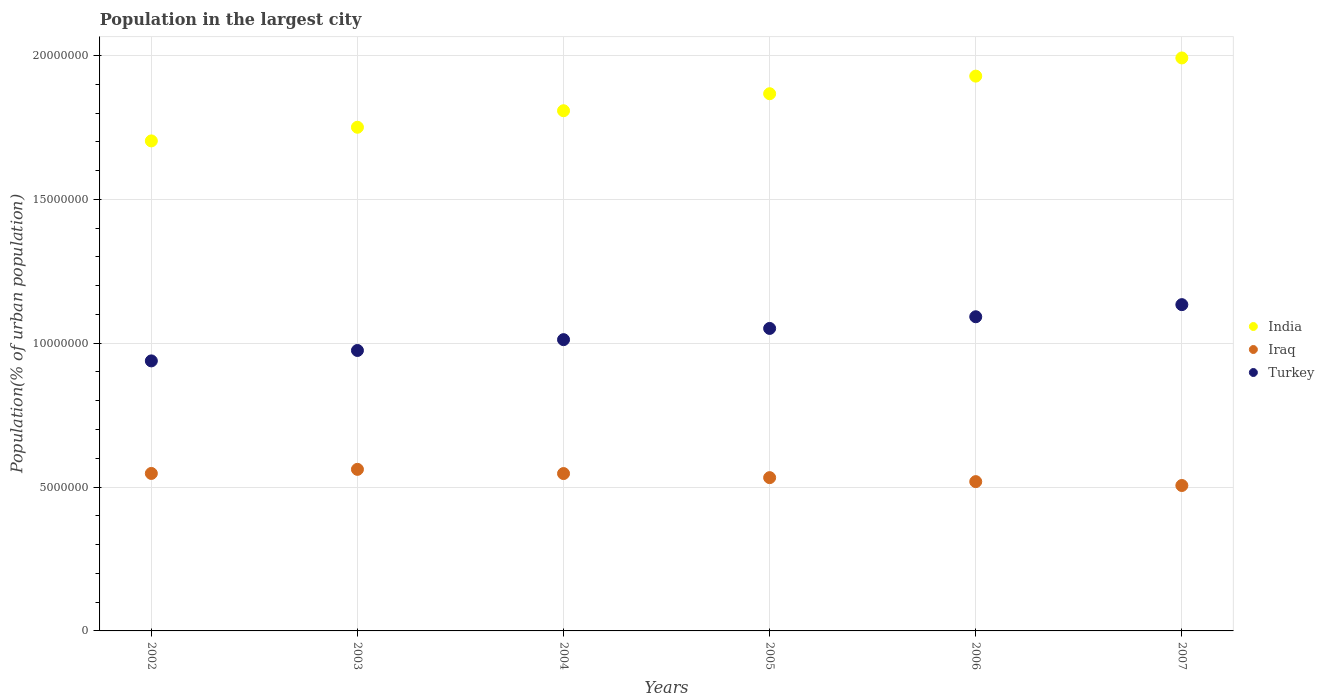Is the number of dotlines equal to the number of legend labels?
Make the answer very short. Yes. What is the population in the largest city in Turkey in 2006?
Make the answer very short. 1.09e+07. Across all years, what is the maximum population in the largest city in Turkey?
Ensure brevity in your answer.  1.13e+07. Across all years, what is the minimum population in the largest city in Turkey?
Give a very brief answer. 9.38e+06. In which year was the population in the largest city in Iraq maximum?
Offer a very short reply. 2003. In which year was the population in the largest city in Iraq minimum?
Give a very brief answer. 2007. What is the total population in the largest city in India in the graph?
Your answer should be very brief. 1.10e+08. What is the difference between the population in the largest city in Turkey in 2004 and that in 2006?
Make the answer very short. -7.95e+05. What is the difference between the population in the largest city in Iraq in 2005 and the population in the largest city in India in 2007?
Provide a succinct answer. -1.46e+07. What is the average population in the largest city in Turkey per year?
Provide a short and direct response. 1.03e+07. In the year 2002, what is the difference between the population in the largest city in Iraq and population in the largest city in Turkey?
Provide a short and direct response. -3.91e+06. In how many years, is the population in the largest city in Iraq greater than 11000000 %?
Your answer should be very brief. 0. What is the ratio of the population in the largest city in Iraq in 2003 to that in 2005?
Your response must be concise. 1.05. What is the difference between the highest and the second highest population in the largest city in Iraq?
Your answer should be compact. 1.42e+05. What is the difference between the highest and the lowest population in the largest city in India?
Keep it short and to the point. 2.88e+06. In how many years, is the population in the largest city in Iraq greater than the average population in the largest city in Iraq taken over all years?
Offer a very short reply. 3. Is the population in the largest city in Turkey strictly greater than the population in the largest city in India over the years?
Provide a short and direct response. No. How many dotlines are there?
Make the answer very short. 3. How many years are there in the graph?
Ensure brevity in your answer.  6. What is the difference between two consecutive major ticks on the Y-axis?
Ensure brevity in your answer.  5.00e+06. Are the values on the major ticks of Y-axis written in scientific E-notation?
Your response must be concise. No. Where does the legend appear in the graph?
Ensure brevity in your answer.  Center right. How are the legend labels stacked?
Provide a short and direct response. Vertical. What is the title of the graph?
Ensure brevity in your answer.  Population in the largest city. Does "Guatemala" appear as one of the legend labels in the graph?
Make the answer very short. No. What is the label or title of the Y-axis?
Your answer should be very brief. Population(% of urban population). What is the Population(% of urban population) of India in 2002?
Offer a terse response. 1.70e+07. What is the Population(% of urban population) of Iraq in 2002?
Provide a short and direct response. 5.47e+06. What is the Population(% of urban population) in Turkey in 2002?
Your answer should be very brief. 9.38e+06. What is the Population(% of urban population) of India in 2003?
Provide a succinct answer. 1.75e+07. What is the Population(% of urban population) in Iraq in 2003?
Keep it short and to the point. 5.62e+06. What is the Population(% of urban population) of Turkey in 2003?
Provide a succinct answer. 9.75e+06. What is the Population(% of urban population) of India in 2004?
Your answer should be very brief. 1.81e+07. What is the Population(% of urban population) of Iraq in 2004?
Offer a very short reply. 5.47e+06. What is the Population(% of urban population) in Turkey in 2004?
Keep it short and to the point. 1.01e+07. What is the Population(% of urban population) in India in 2005?
Keep it short and to the point. 1.87e+07. What is the Population(% of urban population) in Iraq in 2005?
Your answer should be very brief. 5.33e+06. What is the Population(% of urban population) in Turkey in 2005?
Keep it short and to the point. 1.05e+07. What is the Population(% of urban population) of India in 2006?
Your answer should be very brief. 1.93e+07. What is the Population(% of urban population) in Iraq in 2006?
Ensure brevity in your answer.  5.19e+06. What is the Population(% of urban population) of Turkey in 2006?
Make the answer very short. 1.09e+07. What is the Population(% of urban population) in India in 2007?
Your response must be concise. 1.99e+07. What is the Population(% of urban population) of Iraq in 2007?
Provide a short and direct response. 5.05e+06. What is the Population(% of urban population) of Turkey in 2007?
Offer a very short reply. 1.13e+07. Across all years, what is the maximum Population(% of urban population) in India?
Your answer should be very brief. 1.99e+07. Across all years, what is the maximum Population(% of urban population) of Iraq?
Your response must be concise. 5.62e+06. Across all years, what is the maximum Population(% of urban population) of Turkey?
Give a very brief answer. 1.13e+07. Across all years, what is the minimum Population(% of urban population) in India?
Make the answer very short. 1.70e+07. Across all years, what is the minimum Population(% of urban population) in Iraq?
Give a very brief answer. 5.05e+06. Across all years, what is the minimum Population(% of urban population) of Turkey?
Offer a terse response. 9.38e+06. What is the total Population(% of urban population) of India in the graph?
Provide a short and direct response. 1.10e+08. What is the total Population(% of urban population) in Iraq in the graph?
Make the answer very short. 3.21e+07. What is the total Population(% of urban population) of Turkey in the graph?
Ensure brevity in your answer.  6.20e+07. What is the difference between the Population(% of urban population) in India in 2002 and that in 2003?
Your answer should be very brief. -4.74e+05. What is the difference between the Population(% of urban population) of Iraq in 2002 and that in 2003?
Offer a terse response. -1.42e+05. What is the difference between the Population(% of urban population) in Turkey in 2002 and that in 2003?
Your response must be concise. -3.62e+05. What is the difference between the Population(% of urban population) in India in 2002 and that in 2004?
Your answer should be very brief. -1.05e+06. What is the difference between the Population(% of urban population) in Iraq in 2002 and that in 2004?
Keep it short and to the point. 4024. What is the difference between the Population(% of urban population) in Turkey in 2002 and that in 2004?
Ensure brevity in your answer.  -7.38e+05. What is the difference between the Population(% of urban population) in India in 2002 and that in 2005?
Make the answer very short. -1.64e+06. What is the difference between the Population(% of urban population) of Iraq in 2002 and that in 2005?
Your response must be concise. 1.46e+05. What is the difference between the Population(% of urban population) of Turkey in 2002 and that in 2005?
Give a very brief answer. -1.13e+06. What is the difference between the Population(% of urban population) of India in 2002 and that in 2006?
Offer a very short reply. -2.25e+06. What is the difference between the Population(% of urban population) of Iraq in 2002 and that in 2006?
Keep it short and to the point. 2.84e+05. What is the difference between the Population(% of urban population) in Turkey in 2002 and that in 2006?
Offer a terse response. -1.53e+06. What is the difference between the Population(% of urban population) in India in 2002 and that in 2007?
Make the answer very short. -2.88e+06. What is the difference between the Population(% of urban population) in Iraq in 2002 and that in 2007?
Keep it short and to the point. 4.19e+05. What is the difference between the Population(% of urban population) of Turkey in 2002 and that in 2007?
Make the answer very short. -1.96e+06. What is the difference between the Population(% of urban population) in India in 2003 and that in 2004?
Make the answer very short. -5.74e+05. What is the difference between the Population(% of urban population) of Iraq in 2003 and that in 2004?
Give a very brief answer. 1.46e+05. What is the difference between the Population(% of urban population) in Turkey in 2003 and that in 2004?
Ensure brevity in your answer.  -3.76e+05. What is the difference between the Population(% of urban population) in India in 2003 and that in 2005?
Give a very brief answer. -1.17e+06. What is the difference between the Population(% of urban population) of Iraq in 2003 and that in 2005?
Offer a terse response. 2.88e+05. What is the difference between the Population(% of urban population) of Turkey in 2003 and that in 2005?
Your response must be concise. -7.66e+05. What is the difference between the Population(% of urban population) of India in 2003 and that in 2006?
Your answer should be very brief. -1.78e+06. What is the difference between the Population(% of urban population) of Iraq in 2003 and that in 2006?
Give a very brief answer. 4.26e+05. What is the difference between the Population(% of urban population) of Turkey in 2003 and that in 2006?
Offer a very short reply. -1.17e+06. What is the difference between the Population(% of urban population) of India in 2003 and that in 2007?
Offer a very short reply. -2.41e+06. What is the difference between the Population(% of urban population) of Iraq in 2003 and that in 2007?
Ensure brevity in your answer.  5.61e+05. What is the difference between the Population(% of urban population) in Turkey in 2003 and that in 2007?
Offer a terse response. -1.59e+06. What is the difference between the Population(% of urban population) in India in 2004 and that in 2005?
Your answer should be very brief. -5.91e+05. What is the difference between the Population(% of urban population) of Iraq in 2004 and that in 2005?
Provide a short and direct response. 1.42e+05. What is the difference between the Population(% of urban population) in Turkey in 2004 and that in 2005?
Offer a terse response. -3.90e+05. What is the difference between the Population(% of urban population) in India in 2004 and that in 2006?
Make the answer very short. -1.20e+06. What is the difference between the Population(% of urban population) of Iraq in 2004 and that in 2006?
Your response must be concise. 2.80e+05. What is the difference between the Population(% of urban population) in Turkey in 2004 and that in 2006?
Your answer should be very brief. -7.95e+05. What is the difference between the Population(% of urban population) of India in 2004 and that in 2007?
Offer a terse response. -1.83e+06. What is the difference between the Population(% of urban population) in Iraq in 2004 and that in 2007?
Make the answer very short. 4.15e+05. What is the difference between the Population(% of urban population) of Turkey in 2004 and that in 2007?
Make the answer very short. -1.22e+06. What is the difference between the Population(% of urban population) of India in 2005 and that in 2006?
Your response must be concise. -6.12e+05. What is the difference between the Population(% of urban population) of Iraq in 2005 and that in 2006?
Provide a succinct answer. 1.38e+05. What is the difference between the Population(% of urban population) of Turkey in 2005 and that in 2006?
Your answer should be compact. -4.06e+05. What is the difference between the Population(% of urban population) in India in 2005 and that in 2007?
Offer a terse response. -1.24e+06. What is the difference between the Population(% of urban population) in Iraq in 2005 and that in 2007?
Give a very brief answer. 2.73e+05. What is the difference between the Population(% of urban population) of Turkey in 2005 and that in 2007?
Your answer should be very brief. -8.27e+05. What is the difference between the Population(% of urban population) of India in 2006 and that in 2007?
Offer a very short reply. -6.32e+05. What is the difference between the Population(% of urban population) of Iraq in 2006 and that in 2007?
Make the answer very short. 1.35e+05. What is the difference between the Population(% of urban population) in Turkey in 2006 and that in 2007?
Offer a terse response. -4.21e+05. What is the difference between the Population(% of urban population) of India in 2002 and the Population(% of urban population) of Iraq in 2003?
Your answer should be compact. 1.14e+07. What is the difference between the Population(% of urban population) of India in 2002 and the Population(% of urban population) of Turkey in 2003?
Make the answer very short. 7.28e+06. What is the difference between the Population(% of urban population) in Iraq in 2002 and the Population(% of urban population) in Turkey in 2003?
Provide a short and direct response. -4.27e+06. What is the difference between the Population(% of urban population) in India in 2002 and the Population(% of urban population) in Iraq in 2004?
Offer a terse response. 1.16e+07. What is the difference between the Population(% of urban population) in India in 2002 and the Population(% of urban population) in Turkey in 2004?
Your response must be concise. 6.91e+06. What is the difference between the Population(% of urban population) in Iraq in 2002 and the Population(% of urban population) in Turkey in 2004?
Provide a short and direct response. -4.65e+06. What is the difference between the Population(% of urban population) in India in 2002 and the Population(% of urban population) in Iraq in 2005?
Provide a succinct answer. 1.17e+07. What is the difference between the Population(% of urban population) in India in 2002 and the Population(% of urban population) in Turkey in 2005?
Your answer should be very brief. 6.52e+06. What is the difference between the Population(% of urban population) of Iraq in 2002 and the Population(% of urban population) of Turkey in 2005?
Give a very brief answer. -5.04e+06. What is the difference between the Population(% of urban population) in India in 2002 and the Population(% of urban population) in Iraq in 2006?
Make the answer very short. 1.18e+07. What is the difference between the Population(% of urban population) in India in 2002 and the Population(% of urban population) in Turkey in 2006?
Offer a very short reply. 6.11e+06. What is the difference between the Population(% of urban population) of Iraq in 2002 and the Population(% of urban population) of Turkey in 2006?
Offer a terse response. -5.45e+06. What is the difference between the Population(% of urban population) of India in 2002 and the Population(% of urban population) of Iraq in 2007?
Provide a succinct answer. 1.20e+07. What is the difference between the Population(% of urban population) in India in 2002 and the Population(% of urban population) in Turkey in 2007?
Give a very brief answer. 5.69e+06. What is the difference between the Population(% of urban population) in Iraq in 2002 and the Population(% of urban population) in Turkey in 2007?
Offer a terse response. -5.87e+06. What is the difference between the Population(% of urban population) in India in 2003 and the Population(% of urban population) in Iraq in 2004?
Your answer should be very brief. 1.20e+07. What is the difference between the Population(% of urban population) of India in 2003 and the Population(% of urban population) of Turkey in 2004?
Make the answer very short. 7.38e+06. What is the difference between the Population(% of urban population) in Iraq in 2003 and the Population(% of urban population) in Turkey in 2004?
Offer a terse response. -4.51e+06. What is the difference between the Population(% of urban population) in India in 2003 and the Population(% of urban population) in Iraq in 2005?
Provide a succinct answer. 1.22e+07. What is the difference between the Population(% of urban population) of India in 2003 and the Population(% of urban population) of Turkey in 2005?
Your answer should be compact. 6.99e+06. What is the difference between the Population(% of urban population) in Iraq in 2003 and the Population(% of urban population) in Turkey in 2005?
Offer a terse response. -4.90e+06. What is the difference between the Population(% of urban population) of India in 2003 and the Population(% of urban population) of Iraq in 2006?
Your answer should be compact. 1.23e+07. What is the difference between the Population(% of urban population) of India in 2003 and the Population(% of urban population) of Turkey in 2006?
Your answer should be compact. 6.59e+06. What is the difference between the Population(% of urban population) of Iraq in 2003 and the Population(% of urban population) of Turkey in 2006?
Your response must be concise. -5.30e+06. What is the difference between the Population(% of urban population) of India in 2003 and the Population(% of urban population) of Iraq in 2007?
Your response must be concise. 1.25e+07. What is the difference between the Population(% of urban population) in India in 2003 and the Population(% of urban population) in Turkey in 2007?
Keep it short and to the point. 6.17e+06. What is the difference between the Population(% of urban population) of Iraq in 2003 and the Population(% of urban population) of Turkey in 2007?
Your answer should be compact. -5.72e+06. What is the difference between the Population(% of urban population) in India in 2004 and the Population(% of urban population) in Iraq in 2005?
Your response must be concise. 1.28e+07. What is the difference between the Population(% of urban population) of India in 2004 and the Population(% of urban population) of Turkey in 2005?
Your answer should be compact. 7.57e+06. What is the difference between the Population(% of urban population) of Iraq in 2004 and the Population(% of urban population) of Turkey in 2005?
Offer a terse response. -5.04e+06. What is the difference between the Population(% of urban population) in India in 2004 and the Population(% of urban population) in Iraq in 2006?
Offer a very short reply. 1.29e+07. What is the difference between the Population(% of urban population) of India in 2004 and the Population(% of urban population) of Turkey in 2006?
Make the answer very short. 7.16e+06. What is the difference between the Population(% of urban population) of Iraq in 2004 and the Population(% of urban population) of Turkey in 2006?
Ensure brevity in your answer.  -5.45e+06. What is the difference between the Population(% of urban population) of India in 2004 and the Population(% of urban population) of Iraq in 2007?
Your answer should be compact. 1.30e+07. What is the difference between the Population(% of urban population) of India in 2004 and the Population(% of urban population) of Turkey in 2007?
Your answer should be compact. 6.74e+06. What is the difference between the Population(% of urban population) in Iraq in 2004 and the Population(% of urban population) in Turkey in 2007?
Your answer should be very brief. -5.87e+06. What is the difference between the Population(% of urban population) of India in 2005 and the Population(% of urban population) of Iraq in 2006?
Your response must be concise. 1.35e+07. What is the difference between the Population(% of urban population) of India in 2005 and the Population(% of urban population) of Turkey in 2006?
Your answer should be compact. 7.75e+06. What is the difference between the Population(% of urban population) in Iraq in 2005 and the Population(% of urban population) in Turkey in 2006?
Give a very brief answer. -5.59e+06. What is the difference between the Population(% of urban population) of India in 2005 and the Population(% of urban population) of Iraq in 2007?
Your answer should be very brief. 1.36e+07. What is the difference between the Population(% of urban population) in India in 2005 and the Population(% of urban population) in Turkey in 2007?
Your answer should be very brief. 7.33e+06. What is the difference between the Population(% of urban population) in Iraq in 2005 and the Population(% of urban population) in Turkey in 2007?
Provide a short and direct response. -6.01e+06. What is the difference between the Population(% of urban population) in India in 2006 and the Population(% of urban population) in Iraq in 2007?
Make the answer very short. 1.42e+07. What is the difference between the Population(% of urban population) in India in 2006 and the Population(% of urban population) in Turkey in 2007?
Make the answer very short. 7.94e+06. What is the difference between the Population(% of urban population) of Iraq in 2006 and the Population(% of urban population) of Turkey in 2007?
Your answer should be very brief. -6.15e+06. What is the average Population(% of urban population) of India per year?
Offer a very short reply. 1.84e+07. What is the average Population(% of urban population) of Iraq per year?
Give a very brief answer. 5.35e+06. What is the average Population(% of urban population) of Turkey per year?
Give a very brief answer. 1.03e+07. In the year 2002, what is the difference between the Population(% of urban population) of India and Population(% of urban population) of Iraq?
Your answer should be compact. 1.16e+07. In the year 2002, what is the difference between the Population(% of urban population) in India and Population(% of urban population) in Turkey?
Your answer should be compact. 7.65e+06. In the year 2002, what is the difference between the Population(% of urban population) of Iraq and Population(% of urban population) of Turkey?
Ensure brevity in your answer.  -3.91e+06. In the year 2003, what is the difference between the Population(% of urban population) of India and Population(% of urban population) of Iraq?
Ensure brevity in your answer.  1.19e+07. In the year 2003, what is the difference between the Population(% of urban population) in India and Population(% of urban population) in Turkey?
Offer a very short reply. 7.76e+06. In the year 2003, what is the difference between the Population(% of urban population) of Iraq and Population(% of urban population) of Turkey?
Keep it short and to the point. -4.13e+06. In the year 2004, what is the difference between the Population(% of urban population) in India and Population(% of urban population) in Iraq?
Your answer should be compact. 1.26e+07. In the year 2004, what is the difference between the Population(% of urban population) in India and Population(% of urban population) in Turkey?
Offer a very short reply. 7.96e+06. In the year 2004, what is the difference between the Population(% of urban population) in Iraq and Population(% of urban population) in Turkey?
Your answer should be very brief. -4.65e+06. In the year 2005, what is the difference between the Population(% of urban population) in India and Population(% of urban population) in Iraq?
Keep it short and to the point. 1.33e+07. In the year 2005, what is the difference between the Population(% of urban population) of India and Population(% of urban population) of Turkey?
Make the answer very short. 8.16e+06. In the year 2005, what is the difference between the Population(% of urban population) in Iraq and Population(% of urban population) in Turkey?
Ensure brevity in your answer.  -5.19e+06. In the year 2006, what is the difference between the Population(% of urban population) of India and Population(% of urban population) of Iraq?
Make the answer very short. 1.41e+07. In the year 2006, what is the difference between the Population(% of urban population) in India and Population(% of urban population) in Turkey?
Your answer should be compact. 8.36e+06. In the year 2006, what is the difference between the Population(% of urban population) of Iraq and Population(% of urban population) of Turkey?
Your answer should be compact. -5.73e+06. In the year 2007, what is the difference between the Population(% of urban population) of India and Population(% of urban population) of Iraq?
Make the answer very short. 1.49e+07. In the year 2007, what is the difference between the Population(% of urban population) of India and Population(% of urban population) of Turkey?
Offer a very short reply. 8.57e+06. In the year 2007, what is the difference between the Population(% of urban population) in Iraq and Population(% of urban population) in Turkey?
Ensure brevity in your answer.  -6.29e+06. What is the ratio of the Population(% of urban population) in India in 2002 to that in 2003?
Offer a very short reply. 0.97. What is the ratio of the Population(% of urban population) of Iraq in 2002 to that in 2003?
Provide a short and direct response. 0.97. What is the ratio of the Population(% of urban population) in Turkey in 2002 to that in 2003?
Give a very brief answer. 0.96. What is the ratio of the Population(% of urban population) in India in 2002 to that in 2004?
Keep it short and to the point. 0.94. What is the ratio of the Population(% of urban population) in Iraq in 2002 to that in 2004?
Your answer should be very brief. 1. What is the ratio of the Population(% of urban population) of Turkey in 2002 to that in 2004?
Give a very brief answer. 0.93. What is the ratio of the Population(% of urban population) of India in 2002 to that in 2005?
Provide a short and direct response. 0.91. What is the ratio of the Population(% of urban population) of Iraq in 2002 to that in 2005?
Offer a terse response. 1.03. What is the ratio of the Population(% of urban population) of Turkey in 2002 to that in 2005?
Give a very brief answer. 0.89. What is the ratio of the Population(% of urban population) of India in 2002 to that in 2006?
Ensure brevity in your answer.  0.88. What is the ratio of the Population(% of urban population) in Iraq in 2002 to that in 2006?
Make the answer very short. 1.05. What is the ratio of the Population(% of urban population) in Turkey in 2002 to that in 2006?
Provide a short and direct response. 0.86. What is the ratio of the Population(% of urban population) in India in 2002 to that in 2007?
Ensure brevity in your answer.  0.86. What is the ratio of the Population(% of urban population) in Iraq in 2002 to that in 2007?
Offer a very short reply. 1.08. What is the ratio of the Population(% of urban population) in Turkey in 2002 to that in 2007?
Your answer should be very brief. 0.83. What is the ratio of the Population(% of urban population) in India in 2003 to that in 2004?
Provide a succinct answer. 0.97. What is the ratio of the Population(% of urban population) in Iraq in 2003 to that in 2004?
Your answer should be very brief. 1.03. What is the ratio of the Population(% of urban population) in Turkey in 2003 to that in 2004?
Offer a very short reply. 0.96. What is the ratio of the Population(% of urban population) in India in 2003 to that in 2005?
Your response must be concise. 0.94. What is the ratio of the Population(% of urban population) of Iraq in 2003 to that in 2005?
Provide a short and direct response. 1.05. What is the ratio of the Population(% of urban population) of Turkey in 2003 to that in 2005?
Offer a very short reply. 0.93. What is the ratio of the Population(% of urban population) in India in 2003 to that in 2006?
Provide a short and direct response. 0.91. What is the ratio of the Population(% of urban population) of Iraq in 2003 to that in 2006?
Make the answer very short. 1.08. What is the ratio of the Population(% of urban population) of Turkey in 2003 to that in 2006?
Offer a terse response. 0.89. What is the ratio of the Population(% of urban population) of India in 2003 to that in 2007?
Ensure brevity in your answer.  0.88. What is the ratio of the Population(% of urban population) in Iraq in 2003 to that in 2007?
Offer a terse response. 1.11. What is the ratio of the Population(% of urban population) of Turkey in 2003 to that in 2007?
Offer a very short reply. 0.86. What is the ratio of the Population(% of urban population) in India in 2004 to that in 2005?
Give a very brief answer. 0.97. What is the ratio of the Population(% of urban population) of Iraq in 2004 to that in 2005?
Ensure brevity in your answer.  1.03. What is the ratio of the Population(% of urban population) of Turkey in 2004 to that in 2005?
Your answer should be very brief. 0.96. What is the ratio of the Population(% of urban population) in India in 2004 to that in 2006?
Offer a very short reply. 0.94. What is the ratio of the Population(% of urban population) of Iraq in 2004 to that in 2006?
Provide a succinct answer. 1.05. What is the ratio of the Population(% of urban population) of Turkey in 2004 to that in 2006?
Keep it short and to the point. 0.93. What is the ratio of the Population(% of urban population) in India in 2004 to that in 2007?
Offer a terse response. 0.91. What is the ratio of the Population(% of urban population) of Iraq in 2004 to that in 2007?
Offer a terse response. 1.08. What is the ratio of the Population(% of urban population) of Turkey in 2004 to that in 2007?
Give a very brief answer. 0.89. What is the ratio of the Population(% of urban population) in India in 2005 to that in 2006?
Provide a short and direct response. 0.97. What is the ratio of the Population(% of urban population) of Iraq in 2005 to that in 2006?
Make the answer very short. 1.03. What is the ratio of the Population(% of urban population) of Turkey in 2005 to that in 2006?
Provide a succinct answer. 0.96. What is the ratio of the Population(% of urban population) of India in 2005 to that in 2007?
Keep it short and to the point. 0.94. What is the ratio of the Population(% of urban population) in Iraq in 2005 to that in 2007?
Make the answer very short. 1.05. What is the ratio of the Population(% of urban population) of Turkey in 2005 to that in 2007?
Keep it short and to the point. 0.93. What is the ratio of the Population(% of urban population) in India in 2006 to that in 2007?
Your answer should be compact. 0.97. What is the ratio of the Population(% of urban population) in Iraq in 2006 to that in 2007?
Provide a short and direct response. 1.03. What is the ratio of the Population(% of urban population) of Turkey in 2006 to that in 2007?
Keep it short and to the point. 0.96. What is the difference between the highest and the second highest Population(% of urban population) in India?
Provide a short and direct response. 6.32e+05. What is the difference between the highest and the second highest Population(% of urban population) in Iraq?
Provide a short and direct response. 1.42e+05. What is the difference between the highest and the second highest Population(% of urban population) in Turkey?
Give a very brief answer. 4.21e+05. What is the difference between the highest and the lowest Population(% of urban population) of India?
Offer a very short reply. 2.88e+06. What is the difference between the highest and the lowest Population(% of urban population) in Iraq?
Provide a succinct answer. 5.61e+05. What is the difference between the highest and the lowest Population(% of urban population) in Turkey?
Provide a succinct answer. 1.96e+06. 